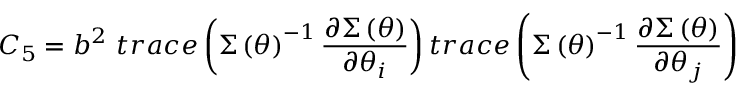<formula> <loc_0><loc_0><loc_500><loc_500>C _ { 5 } = b ^ { 2 } t r a c e \left ( \Sigma \left ( \theta \right ) ^ { - 1 } \frac { \partial \Sigma \left ( \theta \right ) } { \partial \theta _ { i } } \right ) t r a c e \left ( \Sigma \left ( \theta \right ) ^ { - 1 } \frac { \partial \Sigma \left ( \theta \right ) } { \partial \theta _ { j } } \right )</formula> 